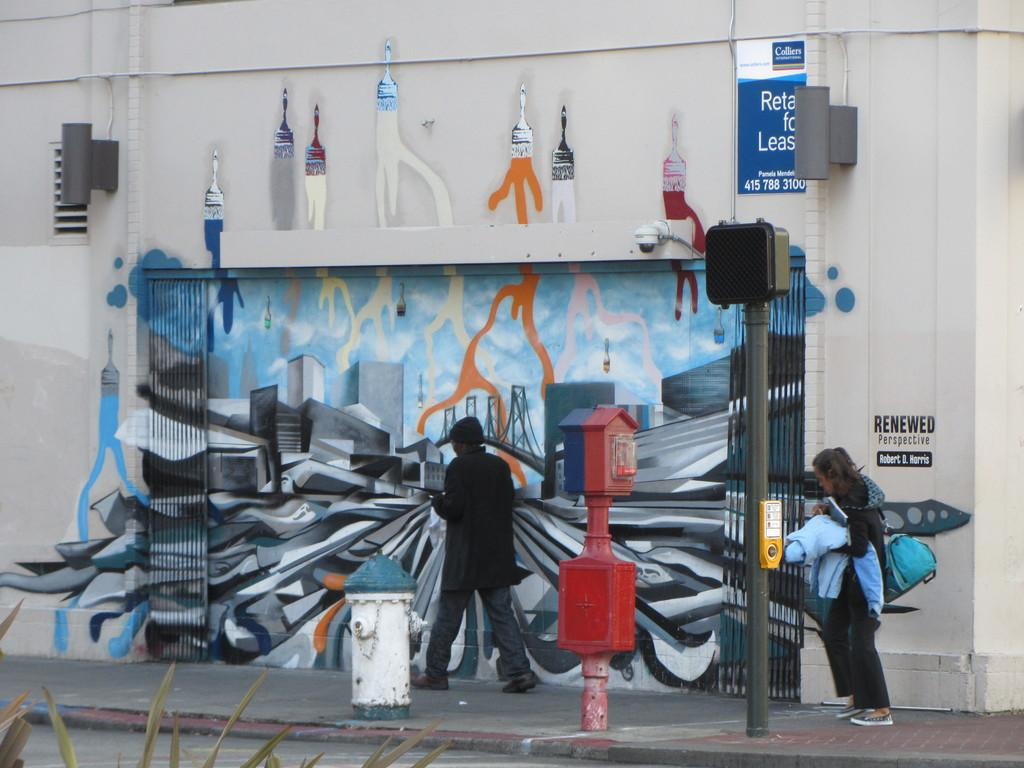What is the main object in the center of the image? There is a hydrant in the center of the image. What other objects can be seen in the image? There are poles in the image. What are the people in the image doing? People are walking on the sidewalk. What is visible in the background of the image? There is a wall in the background of the image. What is on the wall in the image? There is a painting on the wall. What type of juice is being served to the passengers in the image? There are no passengers or juice present in the image; it features a hydrant, poles, people walking, and a wall with a painting. 